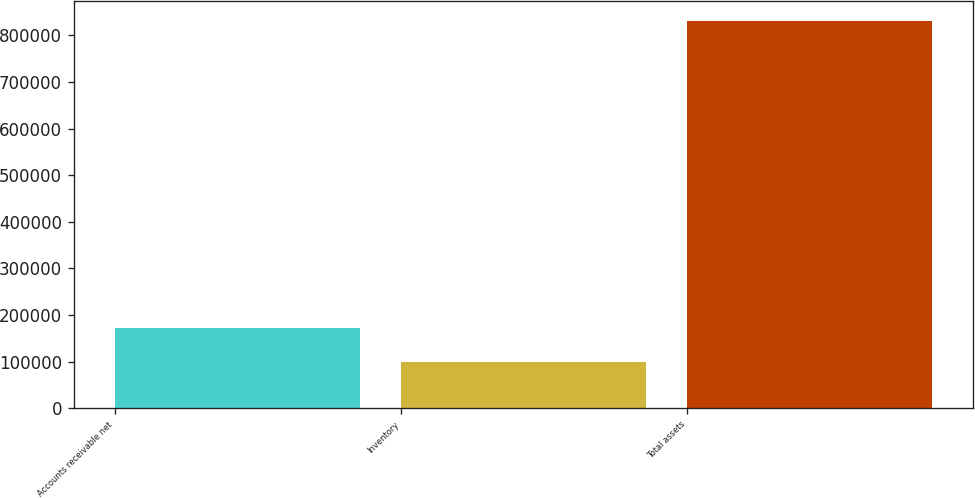Convert chart. <chart><loc_0><loc_0><loc_500><loc_500><bar_chart><fcel>Accounts receivable net<fcel>Inventory<fcel>Total assets<nl><fcel>172512<fcel>99331<fcel>831143<nl></chart> 